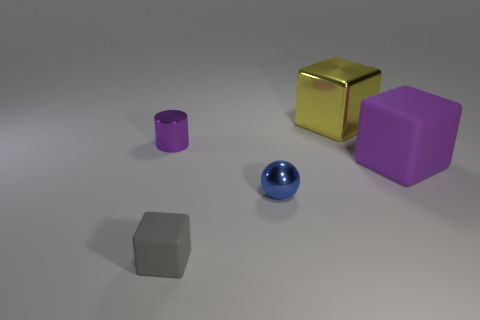What number of small blue metallic objects have the same shape as the small gray object?
Offer a very short reply. 0. What size is the cylinder that is the same material as the ball?
Provide a succinct answer. Small. There is a shiny object in front of the purple object left of the tiny gray block; what color is it?
Your response must be concise. Blue. There is a gray rubber thing; does it have the same shape as the big metal thing behind the cylinder?
Provide a short and direct response. Yes. How many matte cubes have the same size as the blue metal thing?
Your answer should be compact. 1. There is a purple thing that is the same shape as the yellow metallic object; what is its material?
Offer a very short reply. Rubber. There is a large block that is in front of the tiny metal cylinder; is its color the same as the shiny thing that is left of the tiny gray matte cube?
Make the answer very short. Yes. What is the shape of the metal thing that is right of the ball?
Your answer should be very brief. Cube. What is the color of the metallic cylinder?
Give a very brief answer. Purple. What shape is the other large thing that is the same material as the blue thing?
Your answer should be very brief. Cube. 